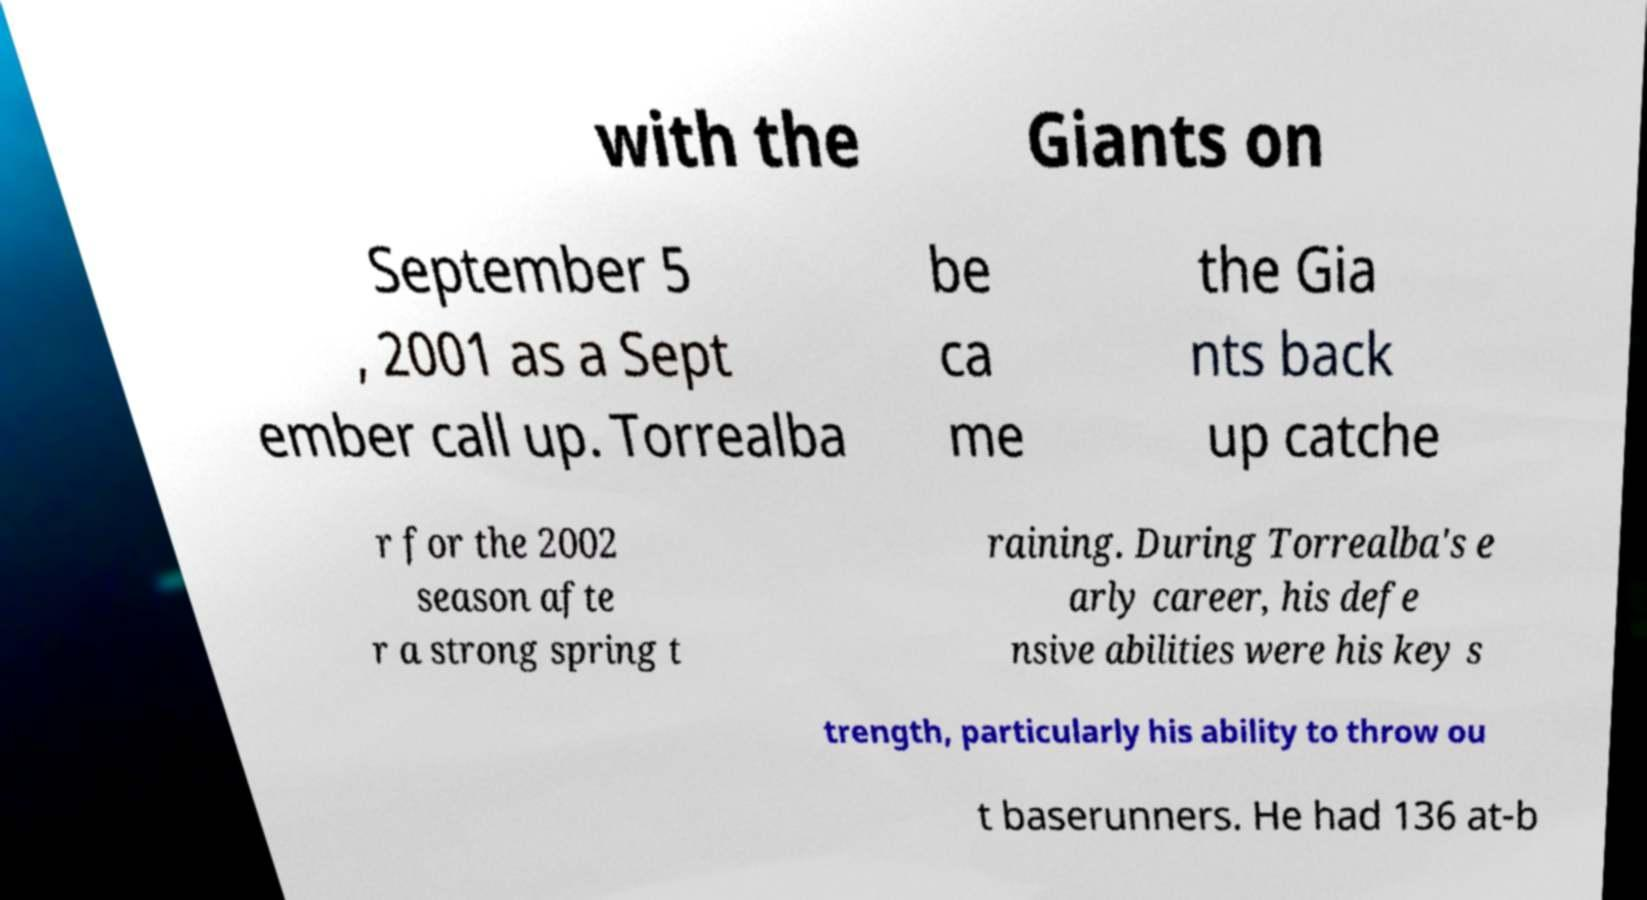Can you read and provide the text displayed in the image?This photo seems to have some interesting text. Can you extract and type it out for me? with the Giants on September 5 , 2001 as a Sept ember call up. Torrealba be ca me the Gia nts back up catche r for the 2002 season afte r a strong spring t raining. During Torrealba's e arly career, his defe nsive abilities were his key s trength, particularly his ability to throw ou t baserunners. He had 136 at-b 